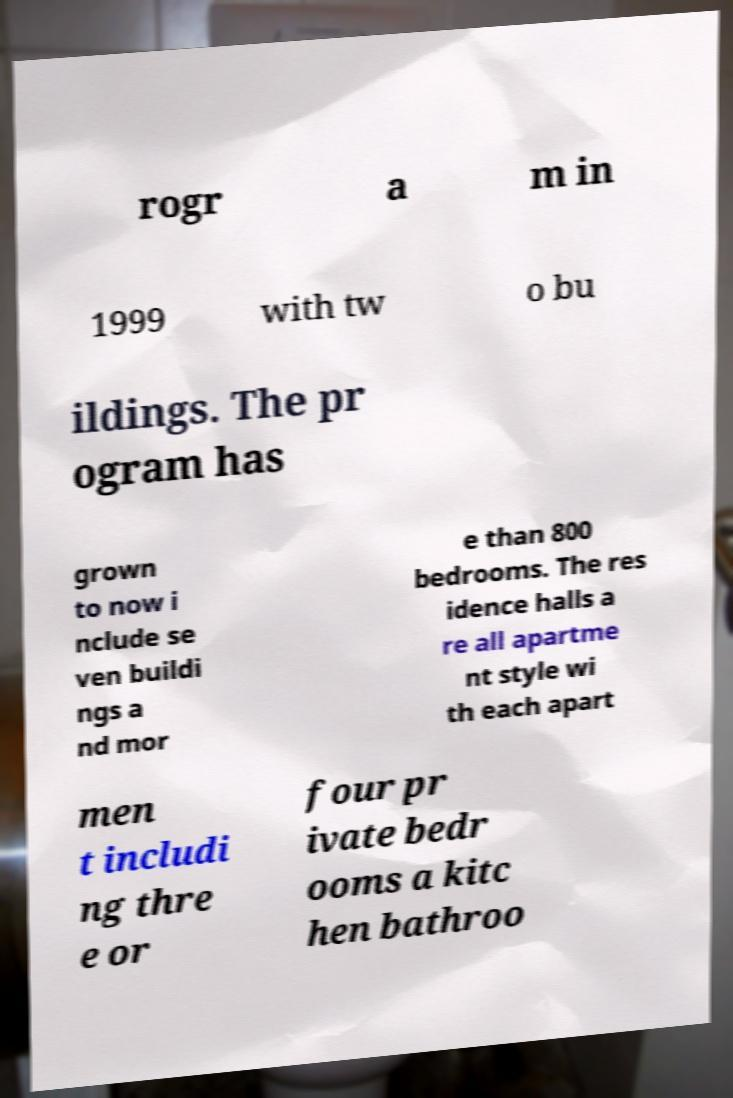I need the written content from this picture converted into text. Can you do that? rogr a m in 1999 with tw o bu ildings. The pr ogram has grown to now i nclude se ven buildi ngs a nd mor e than 800 bedrooms. The res idence halls a re all apartme nt style wi th each apart men t includi ng thre e or four pr ivate bedr ooms a kitc hen bathroo 